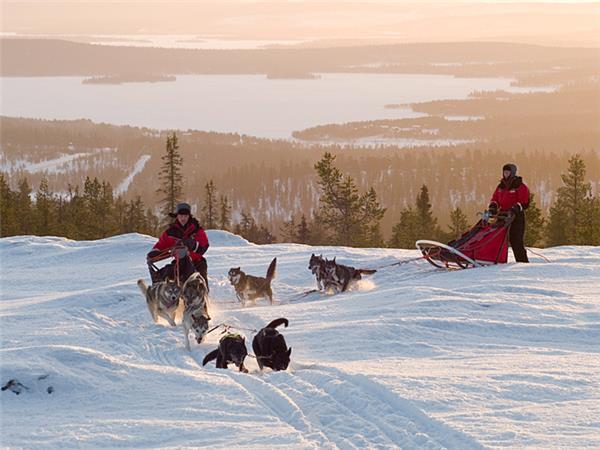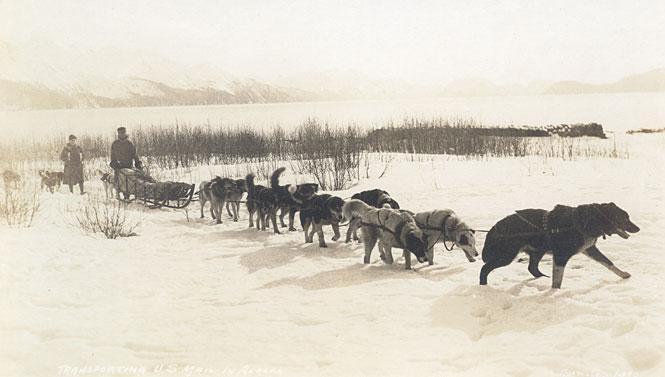The first image is the image on the left, the second image is the image on the right. For the images shown, is this caption "The left image contains only one sled, which is wooden and hitched to at least one leftward-turned dog with a person standing by the dog." true? Answer yes or no. No. The first image is the image on the left, the second image is the image on the right. Assess this claim about the two images: "In the image to the right, the lead dog is a white husky.". Correct or not? Answer yes or no. No. 